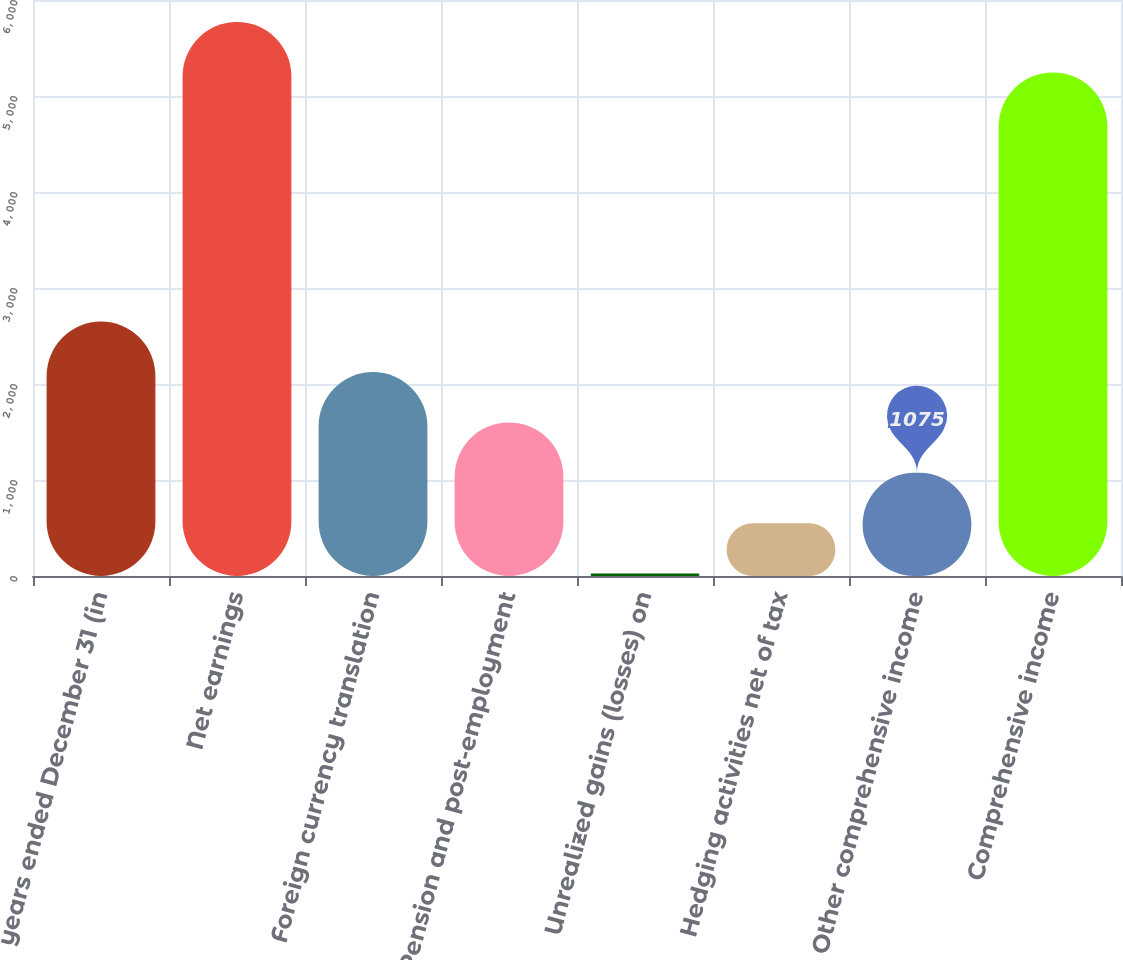<chart> <loc_0><loc_0><loc_500><loc_500><bar_chart><fcel>years ended December 31 (in<fcel>Net earnings<fcel>Foreign currency translation<fcel>Pension and post-employment<fcel>Unrealized gains (losses) on<fcel>Hedging activities net of tax<fcel>Other comprehensive income<fcel>Comprehensive income<nl><fcel>2650<fcel>5771<fcel>2125<fcel>1600<fcel>25<fcel>550<fcel>1075<fcel>5246<nl></chart> 